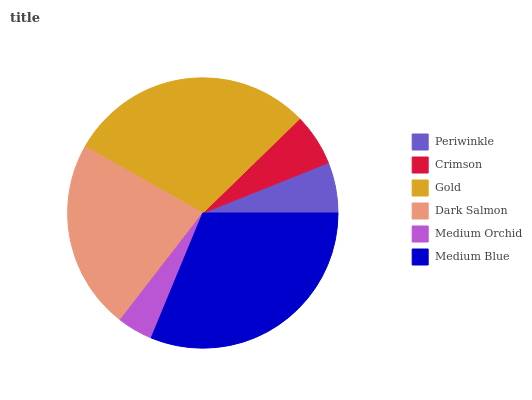Is Medium Orchid the minimum?
Answer yes or no. Yes. Is Medium Blue the maximum?
Answer yes or no. Yes. Is Crimson the minimum?
Answer yes or no. No. Is Crimson the maximum?
Answer yes or no. No. Is Crimson greater than Periwinkle?
Answer yes or no. Yes. Is Periwinkle less than Crimson?
Answer yes or no. Yes. Is Periwinkle greater than Crimson?
Answer yes or no. No. Is Crimson less than Periwinkle?
Answer yes or no. No. Is Dark Salmon the high median?
Answer yes or no. Yes. Is Crimson the low median?
Answer yes or no. Yes. Is Medium Orchid the high median?
Answer yes or no. No. Is Periwinkle the low median?
Answer yes or no. No. 